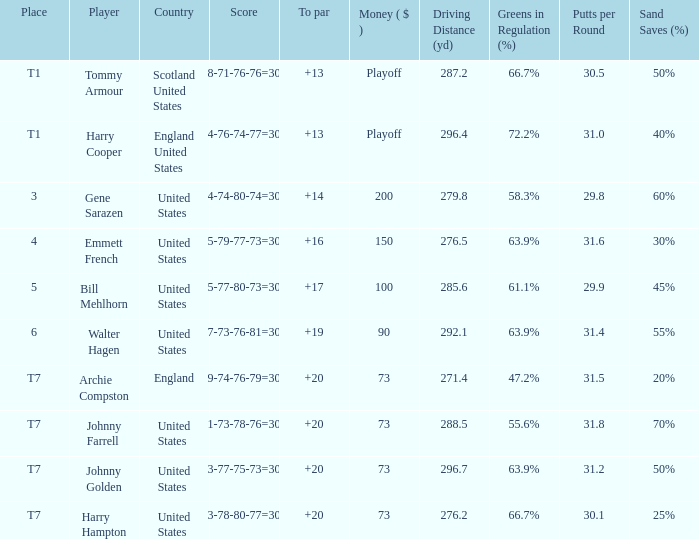What is the score for the United States when Harry Hampton is the player and the money is $73? 73-78-80-77=308. 